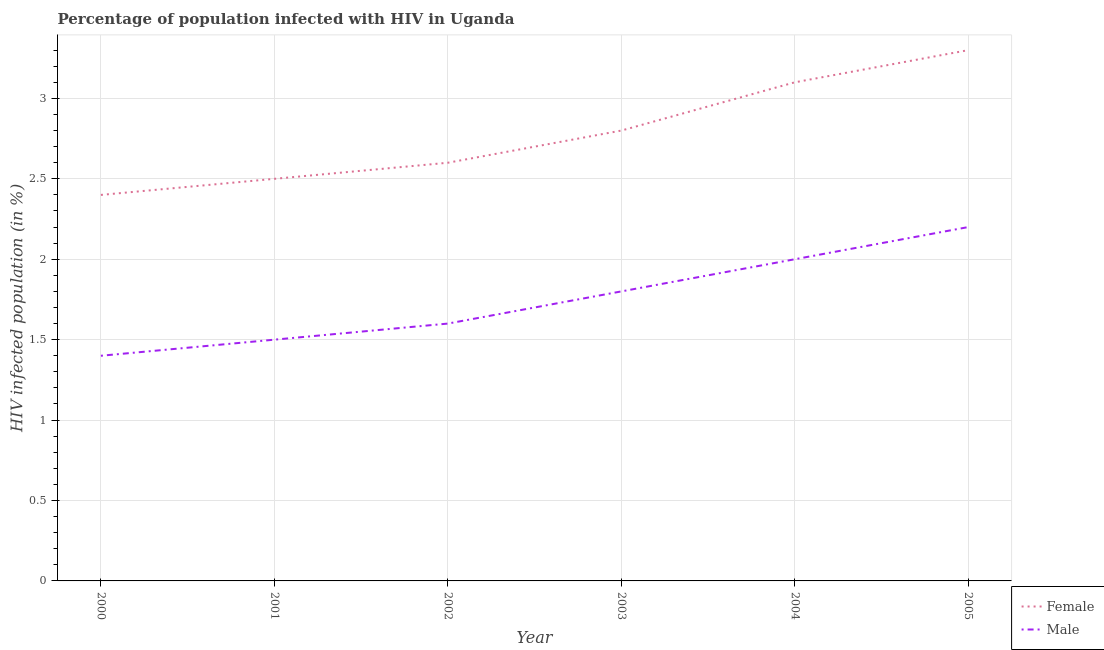How many different coloured lines are there?
Your answer should be compact. 2. Is the number of lines equal to the number of legend labels?
Your response must be concise. Yes. What is the percentage of females who are infected with hiv in 2005?
Make the answer very short. 3.3. What is the total percentage of females who are infected with hiv in the graph?
Offer a terse response. 16.7. What is the difference between the percentage of males who are infected with hiv in 2000 and that in 2001?
Offer a very short reply. -0.1. What is the difference between the percentage of males who are infected with hiv in 2004 and the percentage of females who are infected with hiv in 2000?
Provide a short and direct response. -0.4. What is the average percentage of females who are infected with hiv per year?
Ensure brevity in your answer.  2.78. In the year 2004, what is the difference between the percentage of males who are infected with hiv and percentage of females who are infected with hiv?
Your answer should be compact. -1.1. In how many years, is the percentage of males who are infected with hiv greater than 2.2 %?
Your answer should be compact. 0. What is the ratio of the percentage of males who are infected with hiv in 2000 to that in 2002?
Give a very brief answer. 0.87. Is the difference between the percentage of males who are infected with hiv in 2003 and 2005 greater than the difference between the percentage of females who are infected with hiv in 2003 and 2005?
Keep it short and to the point. Yes. What is the difference between the highest and the second highest percentage of males who are infected with hiv?
Offer a terse response. 0.2. What is the difference between the highest and the lowest percentage of males who are infected with hiv?
Your answer should be compact. 0.8. Is the sum of the percentage of males who are infected with hiv in 2001 and 2002 greater than the maximum percentage of females who are infected with hiv across all years?
Offer a terse response. No. Is the percentage of males who are infected with hiv strictly less than the percentage of females who are infected with hiv over the years?
Provide a short and direct response. Yes. How many lines are there?
Provide a succinct answer. 2. What is the difference between two consecutive major ticks on the Y-axis?
Provide a succinct answer. 0.5. Are the values on the major ticks of Y-axis written in scientific E-notation?
Ensure brevity in your answer.  No. Does the graph contain grids?
Provide a succinct answer. Yes. Where does the legend appear in the graph?
Offer a very short reply. Bottom right. What is the title of the graph?
Your answer should be compact. Percentage of population infected with HIV in Uganda. Does "Frequency of shipment arrival" appear as one of the legend labels in the graph?
Your response must be concise. No. What is the label or title of the X-axis?
Provide a succinct answer. Year. What is the label or title of the Y-axis?
Provide a succinct answer. HIV infected population (in %). What is the HIV infected population (in %) in Male in 2000?
Give a very brief answer. 1.4. What is the HIV infected population (in %) in Male in 2001?
Make the answer very short. 1.5. What is the HIV infected population (in %) of Female in 2002?
Make the answer very short. 2.6. What is the HIV infected population (in %) in Male in 2002?
Provide a succinct answer. 1.6. What is the HIV infected population (in %) of Female in 2004?
Offer a very short reply. 3.1. What is the HIV infected population (in %) in Male in 2005?
Provide a short and direct response. 2.2. Across all years, what is the maximum HIV infected population (in %) in Male?
Provide a short and direct response. 2.2. What is the difference between the HIV infected population (in %) of Female in 2000 and that in 2001?
Offer a very short reply. -0.1. What is the difference between the HIV infected population (in %) of Female in 2000 and that in 2002?
Your response must be concise. -0.2. What is the difference between the HIV infected population (in %) in Male in 2000 and that in 2002?
Offer a terse response. -0.2. What is the difference between the HIV infected population (in %) in Female in 2000 and that in 2003?
Your answer should be very brief. -0.4. What is the difference between the HIV infected population (in %) in Male in 2000 and that in 2004?
Make the answer very short. -0.6. What is the difference between the HIV infected population (in %) in Female in 2001 and that in 2002?
Offer a terse response. -0.1. What is the difference between the HIV infected population (in %) in Male in 2001 and that in 2002?
Give a very brief answer. -0.1. What is the difference between the HIV infected population (in %) of Female in 2001 and that in 2003?
Your response must be concise. -0.3. What is the difference between the HIV infected population (in %) in Female in 2001 and that in 2004?
Offer a terse response. -0.6. What is the difference between the HIV infected population (in %) of Male in 2001 and that in 2004?
Your answer should be compact. -0.5. What is the difference between the HIV infected population (in %) in Female in 2002 and that in 2003?
Make the answer very short. -0.2. What is the difference between the HIV infected population (in %) in Male in 2002 and that in 2003?
Provide a succinct answer. -0.2. What is the difference between the HIV infected population (in %) in Female in 2002 and that in 2004?
Provide a short and direct response. -0.5. What is the difference between the HIV infected population (in %) in Female in 2002 and that in 2005?
Provide a short and direct response. -0.7. What is the difference between the HIV infected population (in %) of Male in 2002 and that in 2005?
Ensure brevity in your answer.  -0.6. What is the difference between the HIV infected population (in %) in Female in 2003 and that in 2004?
Ensure brevity in your answer.  -0.3. What is the difference between the HIV infected population (in %) of Male in 2003 and that in 2004?
Provide a short and direct response. -0.2. What is the difference between the HIV infected population (in %) in Female in 2003 and that in 2005?
Provide a short and direct response. -0.5. What is the difference between the HIV infected population (in %) of Male in 2003 and that in 2005?
Offer a very short reply. -0.4. What is the difference between the HIV infected population (in %) of Female in 2004 and that in 2005?
Keep it short and to the point. -0.2. What is the difference between the HIV infected population (in %) in Female in 2000 and the HIV infected population (in %) in Male in 2002?
Your answer should be very brief. 0.8. What is the difference between the HIV infected population (in %) of Female in 2000 and the HIV infected population (in %) of Male in 2003?
Your answer should be compact. 0.6. What is the difference between the HIV infected population (in %) in Female in 2000 and the HIV infected population (in %) in Male in 2004?
Your answer should be very brief. 0.4. What is the difference between the HIV infected population (in %) in Female in 2001 and the HIV infected population (in %) in Male in 2002?
Keep it short and to the point. 0.9. What is the difference between the HIV infected population (in %) of Female in 2001 and the HIV infected population (in %) of Male in 2004?
Your answer should be compact. 0.5. What is the difference between the HIV infected population (in %) in Female in 2001 and the HIV infected population (in %) in Male in 2005?
Your response must be concise. 0.3. What is the difference between the HIV infected population (in %) of Female in 2002 and the HIV infected population (in %) of Male in 2004?
Keep it short and to the point. 0.6. What is the average HIV infected population (in %) of Female per year?
Provide a short and direct response. 2.78. What is the average HIV infected population (in %) in Male per year?
Offer a terse response. 1.75. In the year 2001, what is the difference between the HIV infected population (in %) in Female and HIV infected population (in %) in Male?
Offer a very short reply. 1. In the year 2004, what is the difference between the HIV infected population (in %) in Female and HIV infected population (in %) in Male?
Your answer should be very brief. 1.1. What is the ratio of the HIV infected population (in %) in Female in 2000 to that in 2002?
Your answer should be compact. 0.92. What is the ratio of the HIV infected population (in %) in Male in 2000 to that in 2002?
Your answer should be compact. 0.88. What is the ratio of the HIV infected population (in %) of Male in 2000 to that in 2003?
Your answer should be compact. 0.78. What is the ratio of the HIV infected population (in %) of Female in 2000 to that in 2004?
Provide a short and direct response. 0.77. What is the ratio of the HIV infected population (in %) in Female in 2000 to that in 2005?
Make the answer very short. 0.73. What is the ratio of the HIV infected population (in %) in Male in 2000 to that in 2005?
Make the answer very short. 0.64. What is the ratio of the HIV infected population (in %) in Female in 2001 to that in 2002?
Provide a short and direct response. 0.96. What is the ratio of the HIV infected population (in %) in Female in 2001 to that in 2003?
Offer a very short reply. 0.89. What is the ratio of the HIV infected population (in %) in Male in 2001 to that in 2003?
Keep it short and to the point. 0.83. What is the ratio of the HIV infected population (in %) in Female in 2001 to that in 2004?
Make the answer very short. 0.81. What is the ratio of the HIV infected population (in %) of Male in 2001 to that in 2004?
Offer a very short reply. 0.75. What is the ratio of the HIV infected population (in %) in Female in 2001 to that in 2005?
Your response must be concise. 0.76. What is the ratio of the HIV infected population (in %) of Male in 2001 to that in 2005?
Your response must be concise. 0.68. What is the ratio of the HIV infected population (in %) in Female in 2002 to that in 2004?
Offer a terse response. 0.84. What is the ratio of the HIV infected population (in %) in Female in 2002 to that in 2005?
Your answer should be very brief. 0.79. What is the ratio of the HIV infected population (in %) of Male in 2002 to that in 2005?
Make the answer very short. 0.73. What is the ratio of the HIV infected population (in %) in Female in 2003 to that in 2004?
Give a very brief answer. 0.9. What is the ratio of the HIV infected population (in %) of Female in 2003 to that in 2005?
Provide a short and direct response. 0.85. What is the ratio of the HIV infected population (in %) in Male in 2003 to that in 2005?
Your response must be concise. 0.82. What is the ratio of the HIV infected population (in %) in Female in 2004 to that in 2005?
Keep it short and to the point. 0.94. What is the ratio of the HIV infected population (in %) of Male in 2004 to that in 2005?
Provide a short and direct response. 0.91. What is the difference between the highest and the lowest HIV infected population (in %) of Female?
Give a very brief answer. 0.9. What is the difference between the highest and the lowest HIV infected population (in %) in Male?
Offer a terse response. 0.8. 